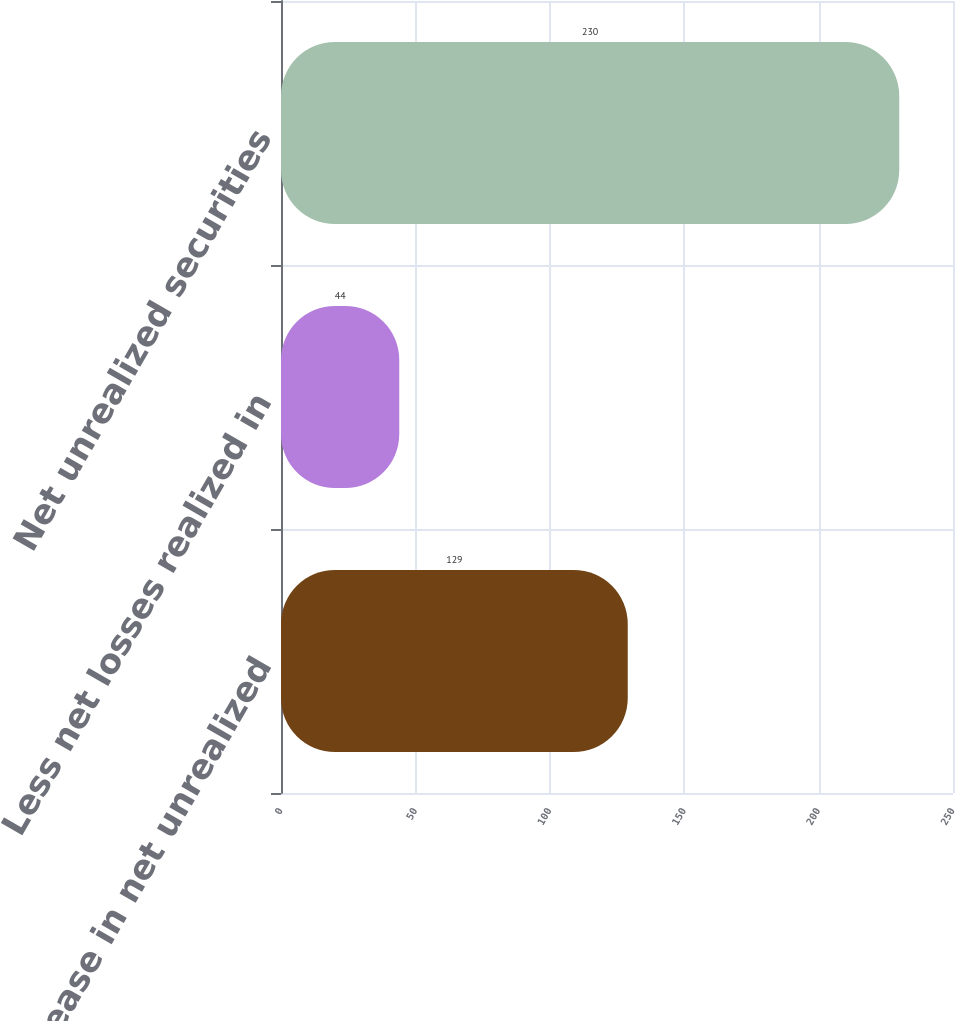Convert chart to OTSL. <chart><loc_0><loc_0><loc_500><loc_500><bar_chart><fcel>Increase in net unrealized<fcel>Less net losses realized in<fcel>Net unrealized securities<nl><fcel>129<fcel>44<fcel>230<nl></chart> 